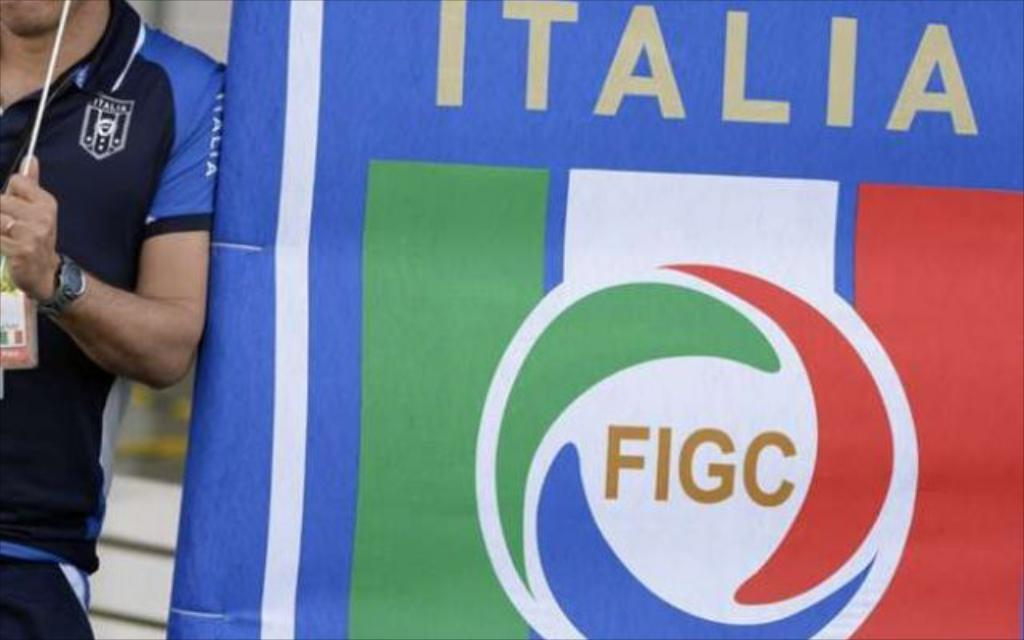<image>
Describe the image concisely. A man leans by a banner for Italy saying Figc in the center. 